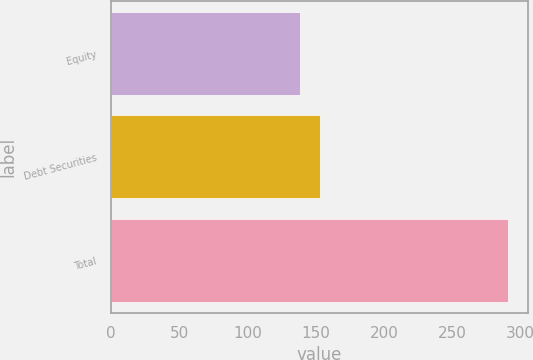<chart> <loc_0><loc_0><loc_500><loc_500><bar_chart><fcel>Equity<fcel>Debt Securities<fcel>Total<nl><fcel>138.1<fcel>153.39<fcel>291<nl></chart> 